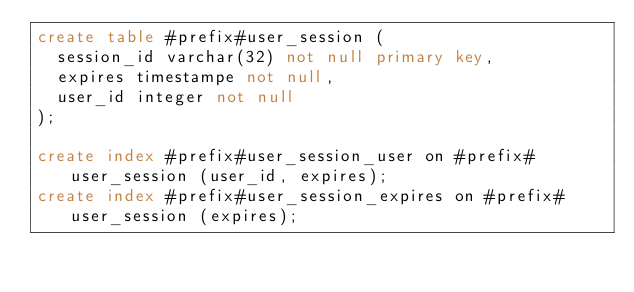<code> <loc_0><loc_0><loc_500><loc_500><_SQL_>create table #prefix#user_session (
	session_id varchar(32) not null primary key,
	expires timestampe not null,
	user_id integer not null
);

create index #prefix#user_session_user on #prefix#user_session (user_id, expires);
create index #prefix#user_session_expires on #prefix#user_session (expires);
</code> 